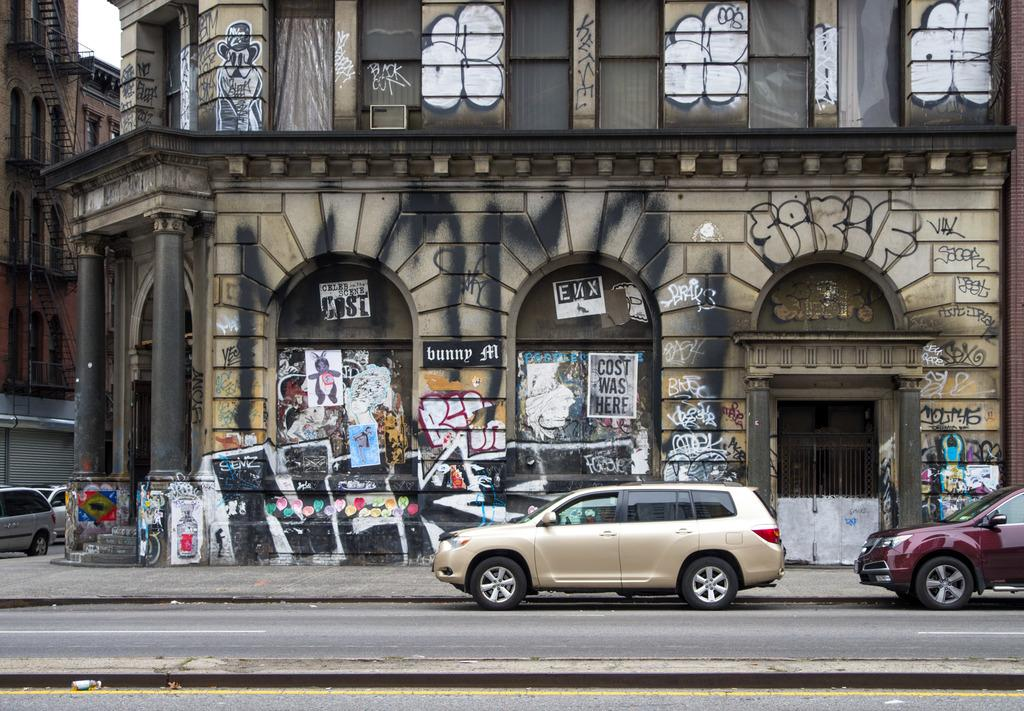What type of artwork can be seen on the buildings in the image? There are buildings with graffiti in the image. What type of cooking appliances are visible in the image? There are grills in the image. What architectural features are present in the image? There are staircases and railings in the image. What is visible in the sky in the image? The sky is visible in the image. What type of transportation is present on the road in the image? Motor vehicles are present on the road in the image. What type of potato is being used as a decoration on the buildings in the image? There are no potatoes present in the image; the artwork on the buildings is graffiti. What type of art can be seen on the railings in the image? There is no art specifically on the railings in the image; the artwork is on the buildings. 